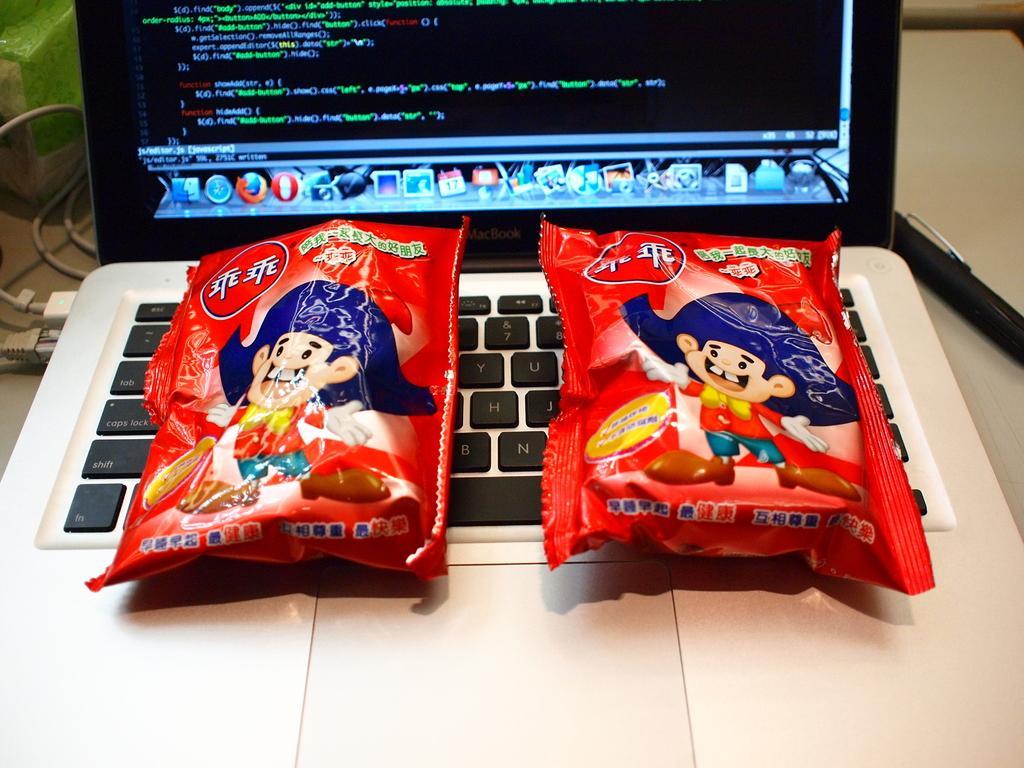In one or two sentences, can you explain what this image depicts? In the center of the image a laptop is present. On laptop we can see two packets are there. On the left side of the image wires are present. 